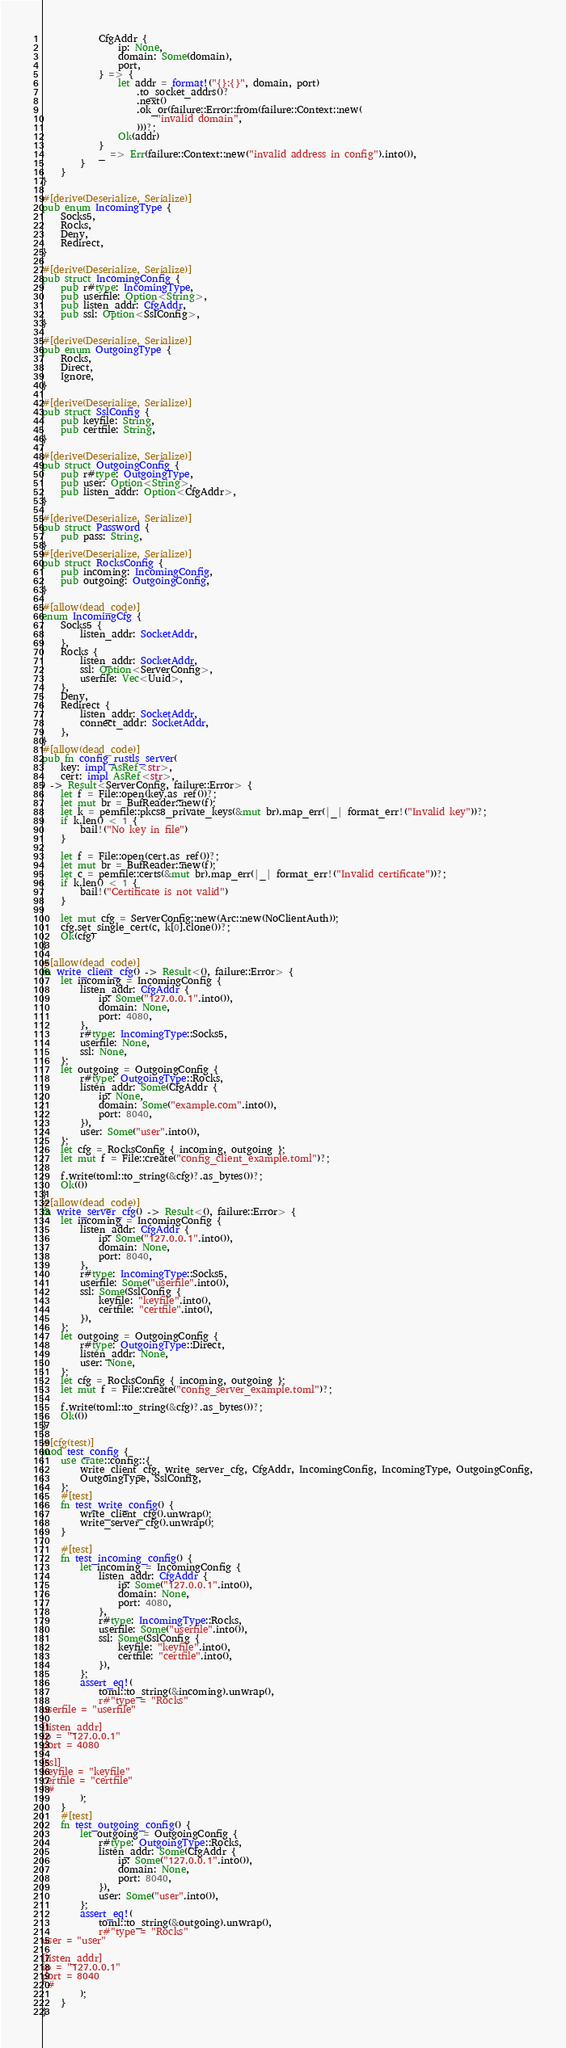Convert code to text. <code><loc_0><loc_0><loc_500><loc_500><_Rust_>            CfgAddr {
                ip: None,
                domain: Some(domain),
                port,
            } => {
                let addr = format!("{}:{}", domain, port)
                    .to_socket_addrs()?
                    .next()
                    .ok_or(failure::Error::from(failure::Context::new(
                        "invalid domain",
                    )))?;
                Ok(addr)
            }
            _ => Err(failure::Context::new("invalid address in config").into()),
        }
    }
}

#[derive(Deserialize, Serialize)]
pub enum IncomingType {
    Socks5,
    Rocks,
    Deny,
    Redirect,
}

#[derive(Deserialize, Serialize)]
pub struct IncomingConfig {
    pub r#type: IncomingType,
    pub userfile: Option<String>,
    pub listen_addr: CfgAddr,
    pub ssl: Option<SslConfig>,
}

#[derive(Deserialize, Serialize)]
pub enum OutgoingType {
    Rocks,
    Direct,
    Ignore,
}

#[derive(Deserialize, Serialize)]
pub struct SslConfig {
    pub keyfile: String,
    pub certfile: String,
}

#[derive(Deserialize, Serialize)]
pub struct OutgoingConfig {
    pub r#type: OutgoingType,
    pub user: Option<String>,
    pub listen_addr: Option<CfgAddr>,
}

#[derive(Deserialize, Serialize)]
pub struct Password {
    pub pass: String,
}
#[derive(Deserialize, Serialize)]
pub struct RocksConfig {
    pub incoming: IncomingConfig,
    pub outgoing: OutgoingConfig,
}

#[allow(dead_code)]
enum IncomingCfg {
    Socks5 {
        listen_addr: SocketAddr,
    },
    Rocks {
        listen_addr: SocketAddr,
        ssl: Option<ServerConfig>,
        userfile: Vec<Uuid>,
    },
    Deny,
    Redirect {
        listen_addr: SocketAddr,
        connect_addr: SocketAddr,
    },
}
#[allow(dead_code)]
pub fn config_rustls_server(
    key: impl AsRef<str>,
    cert: impl AsRef<str>,
) -> Result<ServerConfig, failure::Error> {
    let f = File::open(key.as_ref())?;
    let mut br = BufReader::new(f);
    let k = pemfile::pkcs8_private_keys(&mut br).map_err(|_| format_err!("Invalid key"))?;
    if k.len() < 1 {
        bail!("No key in file")
    }

    let f = File::open(cert.as_ref())?;
    let mut br = BufReader::new(f);
    let c = pemfile::certs(&mut br).map_err(|_| format_err!("Invalid certificate"))?;
    if k.len() < 1 {
        bail!("Certificate is not valid")
    }

    let mut cfg = ServerConfig::new(Arc::new(NoClientAuth));
    cfg.set_single_cert(c, k[0].clone())?;
    Ok(cfg)
}

#[allow(dead_code)]
fn write_client_cfg() -> Result<(), failure::Error> {
    let incoming = IncomingConfig {
        listen_addr: CfgAddr {
            ip: Some("127.0.0.1".into()),
            domain: None,
            port: 4080,
        },
        r#type: IncomingType::Socks5,
        userfile: None,
        ssl: None,
    };
    let outgoing = OutgoingConfig {
        r#type: OutgoingType::Rocks,
        listen_addr: Some(CfgAddr {
            ip: None,
            domain: Some("example.com".into()),
            port: 8040,
        }),
        user: Some("user".into()),
    };
    let cfg = RocksConfig { incoming, outgoing };
    let mut f = File::create("config_client_example.toml")?;

    f.write(toml::to_string(&cfg)?.as_bytes())?;
    Ok(())
}
#[allow(dead_code)]
fn write_server_cfg() -> Result<(), failure::Error> {
    let incoming = IncomingConfig {
        listen_addr: CfgAddr {
            ip: Some("127.0.0.1".into()),
            domain: None,
            port: 8040,
        },
        r#type: IncomingType::Socks5,
        userfile: Some("userfile".into()),
        ssl: Some(SslConfig {
            keyfile: "keyfile".into(),
            certfile: "certfile".into(),
        }),
    };
    let outgoing = OutgoingConfig {
        r#type: OutgoingType::Direct,
        listen_addr: None,
        user: None,
    };
    let cfg = RocksConfig { incoming, outgoing };
    let mut f = File::create("config_server_example.toml")?;

    f.write(toml::to_string(&cfg)?.as_bytes())?;
    Ok(())
}

#[cfg(test)]
mod test_config {
    use crate::config::{
        write_client_cfg, write_server_cfg, CfgAddr, IncomingConfig, IncomingType, OutgoingConfig,
        OutgoingType, SslConfig,
    };
    #[test]
    fn test_write_config() {
        write_client_cfg().unwrap();
        write_server_cfg().unwrap();
    }

    #[test]
    fn test_incoming_config() {
        let incoming = IncomingConfig {
            listen_addr: CfgAddr {
                ip: Some("127.0.0.1".into()),
                domain: None,
                port: 4080,
            },
            r#type: IncomingType::Rocks,
            userfile: Some("userfile".into()),
            ssl: Some(SslConfig {
                keyfile: "keyfile".into(),
                certfile: "certfile".into(),
            }),
        };
        assert_eq!(
            toml::to_string(&incoming).unwrap(),
            r#"type = "Rocks"
userfile = "userfile"

[listen_addr]
ip = "127.0.0.1"
port = 4080

[ssl]
keyfile = "keyfile"
certfile = "certfile"
"#
        );
    }
    #[test]
    fn test_outgoing_config() {
        let outgoing = OutgoingConfig {
            r#type: OutgoingType::Rocks,
            listen_addr: Some(CfgAddr {
                ip: Some("127.0.0.1".into()),
                domain: None,
                port: 8040,
            }),
            user: Some("user".into()),
        };
        assert_eq!(
            toml::to_string(&outgoing).unwrap(),
            r#"type = "Rocks"
user = "user"

[listen_addr]
ip = "127.0.0.1"
port = 8040
"#
        );
    }
}
</code> 